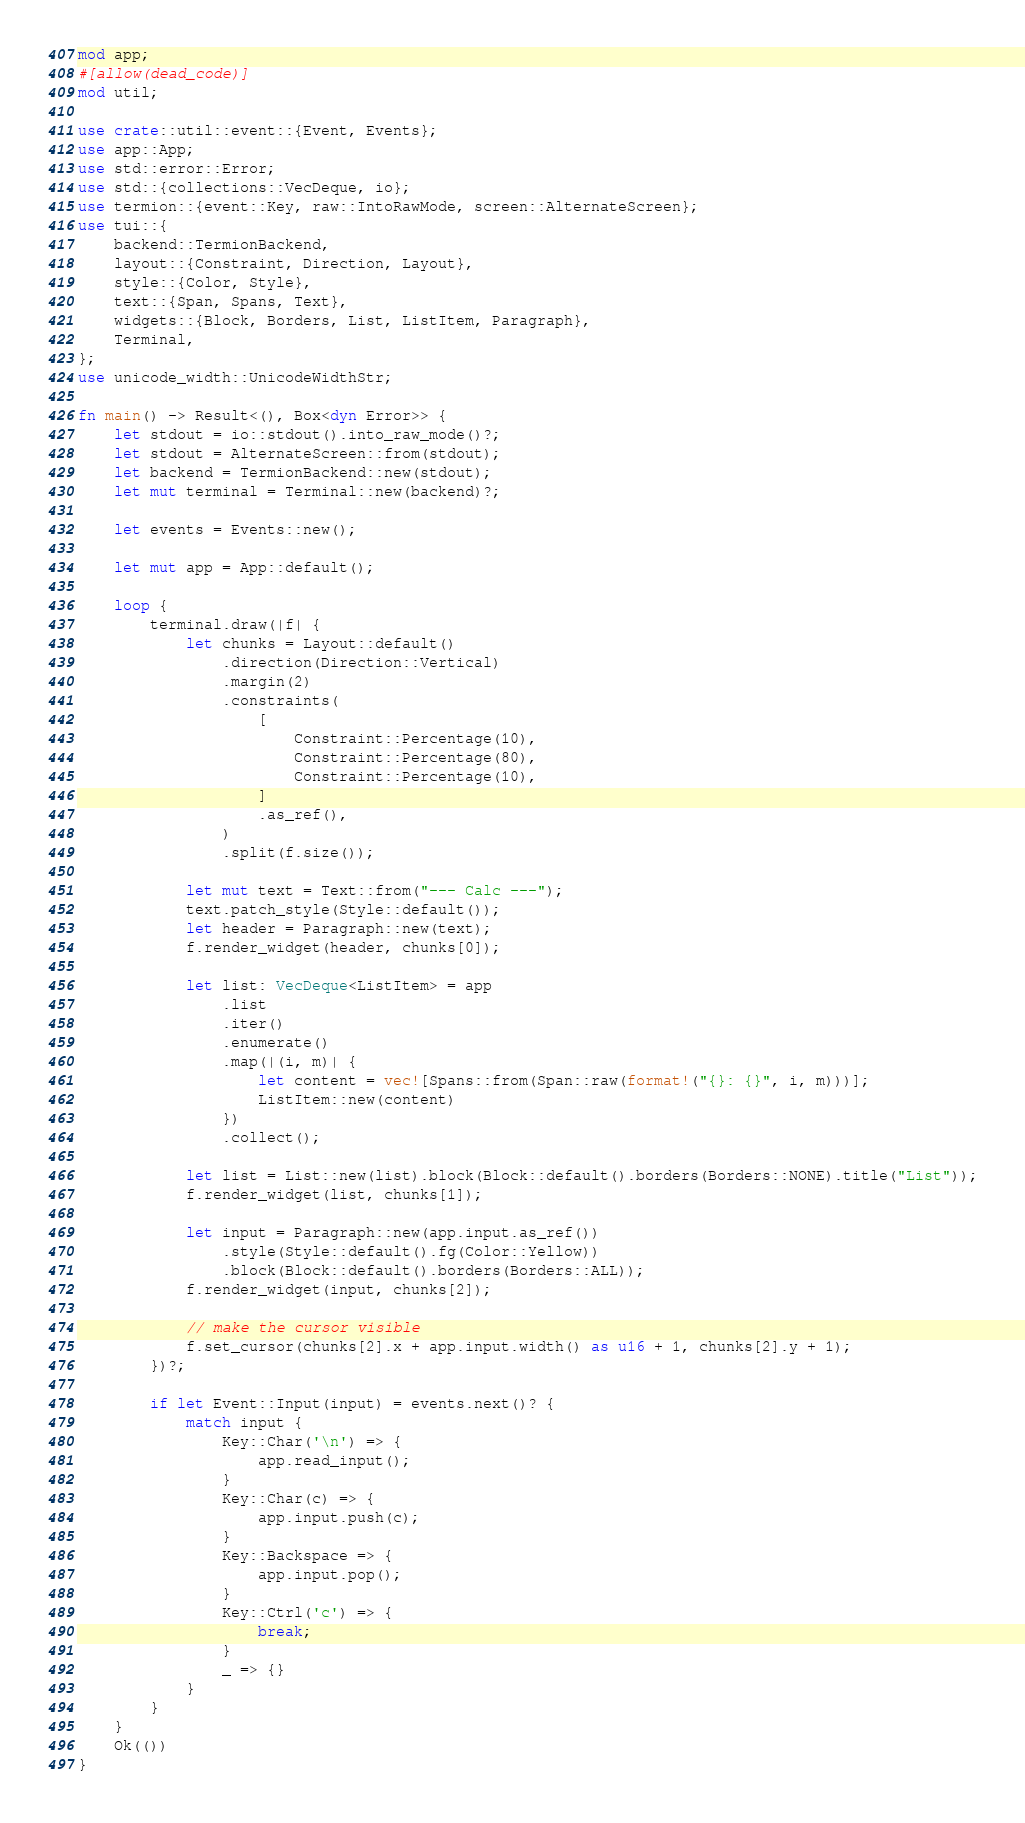Convert code to text. <code><loc_0><loc_0><loc_500><loc_500><_Rust_>mod app;
#[allow(dead_code)]
mod util;

use crate::util::event::{Event, Events};
use app::App;
use std::error::Error;
use std::{collections::VecDeque, io};
use termion::{event::Key, raw::IntoRawMode, screen::AlternateScreen};
use tui::{
    backend::TermionBackend,
    layout::{Constraint, Direction, Layout},
    style::{Color, Style},
    text::{Span, Spans, Text},
    widgets::{Block, Borders, List, ListItem, Paragraph},
    Terminal,
};
use unicode_width::UnicodeWidthStr;

fn main() -> Result<(), Box<dyn Error>> {
    let stdout = io::stdout().into_raw_mode()?;
    let stdout = AlternateScreen::from(stdout);
    let backend = TermionBackend::new(stdout);
    let mut terminal = Terminal::new(backend)?;

    let events = Events::new();

    let mut app = App::default();

    loop {
        terminal.draw(|f| {
            let chunks = Layout::default()
                .direction(Direction::Vertical)
                .margin(2)
                .constraints(
                    [
                        Constraint::Percentage(10),
                        Constraint::Percentage(80),
                        Constraint::Percentage(10),
                    ]
                    .as_ref(),
                )
                .split(f.size());

            let mut text = Text::from("--- Calc ---");
            text.patch_style(Style::default());
            let header = Paragraph::new(text);
            f.render_widget(header, chunks[0]);

            let list: VecDeque<ListItem> = app
                .list
                .iter()
                .enumerate()
                .map(|(i, m)| {
                    let content = vec![Spans::from(Span::raw(format!("{}: {}", i, m)))];
                    ListItem::new(content)
                })
                .collect();

            let list = List::new(list).block(Block::default().borders(Borders::NONE).title("List"));
            f.render_widget(list, chunks[1]);

            let input = Paragraph::new(app.input.as_ref())
                .style(Style::default().fg(Color::Yellow))
                .block(Block::default().borders(Borders::ALL));
            f.render_widget(input, chunks[2]);

            // make the cursor visible
            f.set_cursor(chunks[2].x + app.input.width() as u16 + 1, chunks[2].y + 1);
        })?;

        if let Event::Input(input) = events.next()? {
            match input {
                Key::Char('\n') => {
                    app.read_input();
                }
                Key::Char(c) => {
                    app.input.push(c);
                }
                Key::Backspace => {
                    app.input.pop();
                }
                Key::Ctrl('c') => {
                    break;
                }
                _ => {}
            }
        }
    }
    Ok(())
}
</code> 